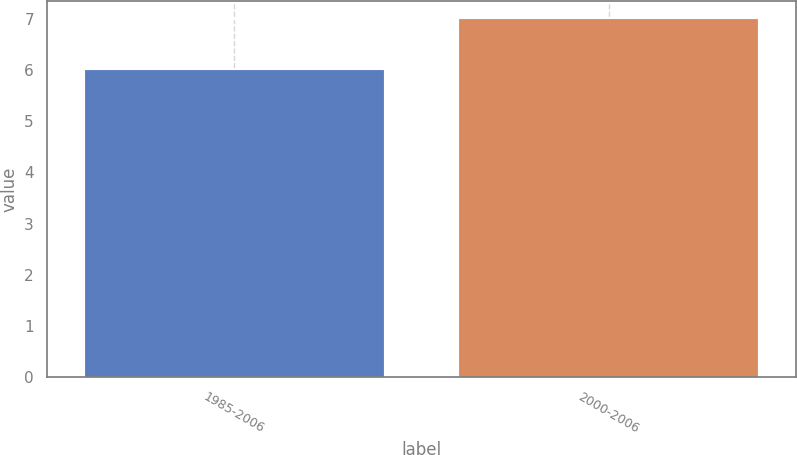<chart> <loc_0><loc_0><loc_500><loc_500><bar_chart><fcel>1985-2006<fcel>2000-2006<nl><fcel>6<fcel>7<nl></chart> 